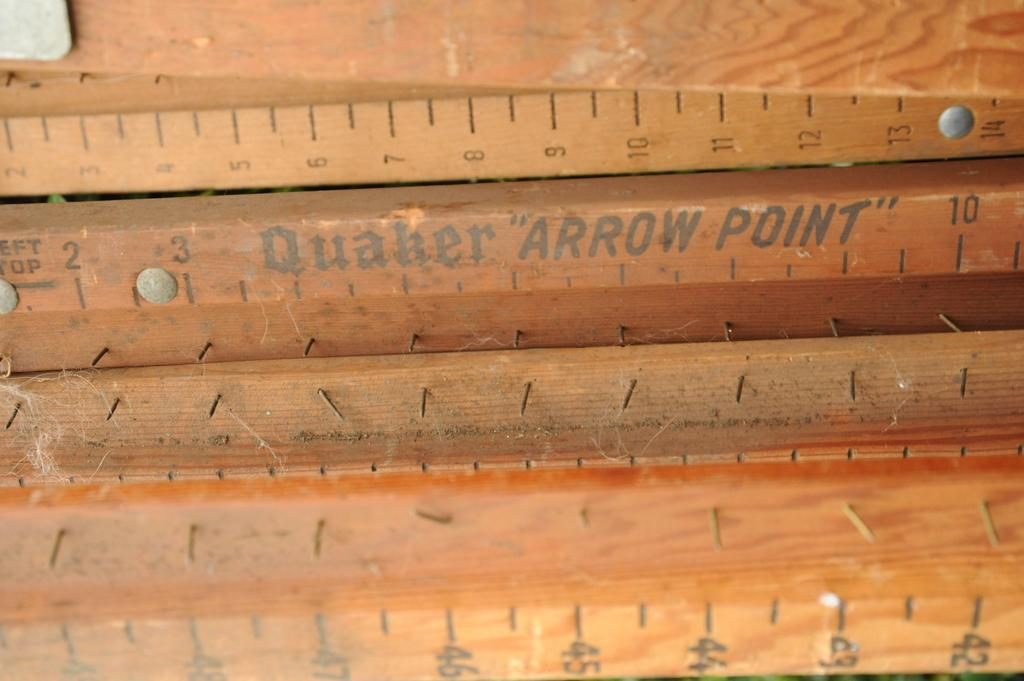<image>
Provide a brief description of the given image. A ruler has the logo for Quaker on the front of it. 